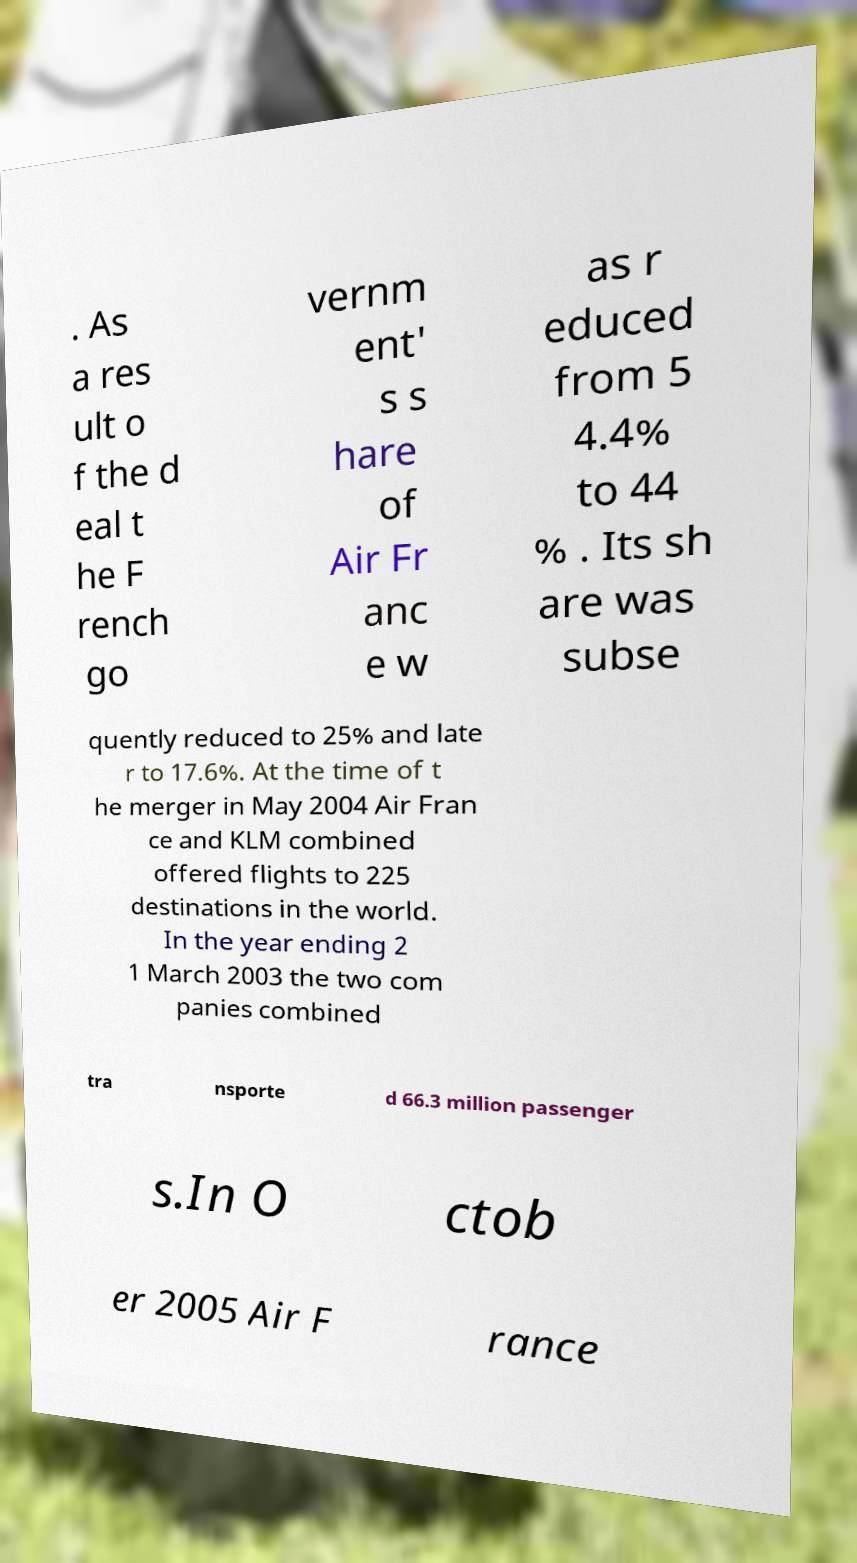Please read and relay the text visible in this image. What does it say? . As a res ult o f the d eal t he F rench go vernm ent' s s hare of Air Fr anc e w as r educed from 5 4.4% to 44 % . Its sh are was subse quently reduced to 25% and late r to 17.6%. At the time of t he merger in May 2004 Air Fran ce and KLM combined offered flights to 225 destinations in the world. In the year ending 2 1 March 2003 the two com panies combined tra nsporte d 66.3 million passenger s.In O ctob er 2005 Air F rance 